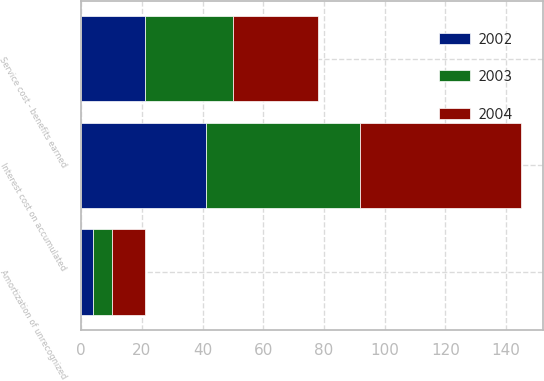<chart> <loc_0><loc_0><loc_500><loc_500><stacked_bar_chart><ecel><fcel>Service cost - benefits earned<fcel>Interest cost on accumulated<fcel>Amortization of unrecognized<nl><fcel>2003<fcel>29<fcel>51<fcel>6<nl><fcel>2004<fcel>28<fcel>53<fcel>11<nl><fcel>2002<fcel>21<fcel>41<fcel>4<nl></chart> 